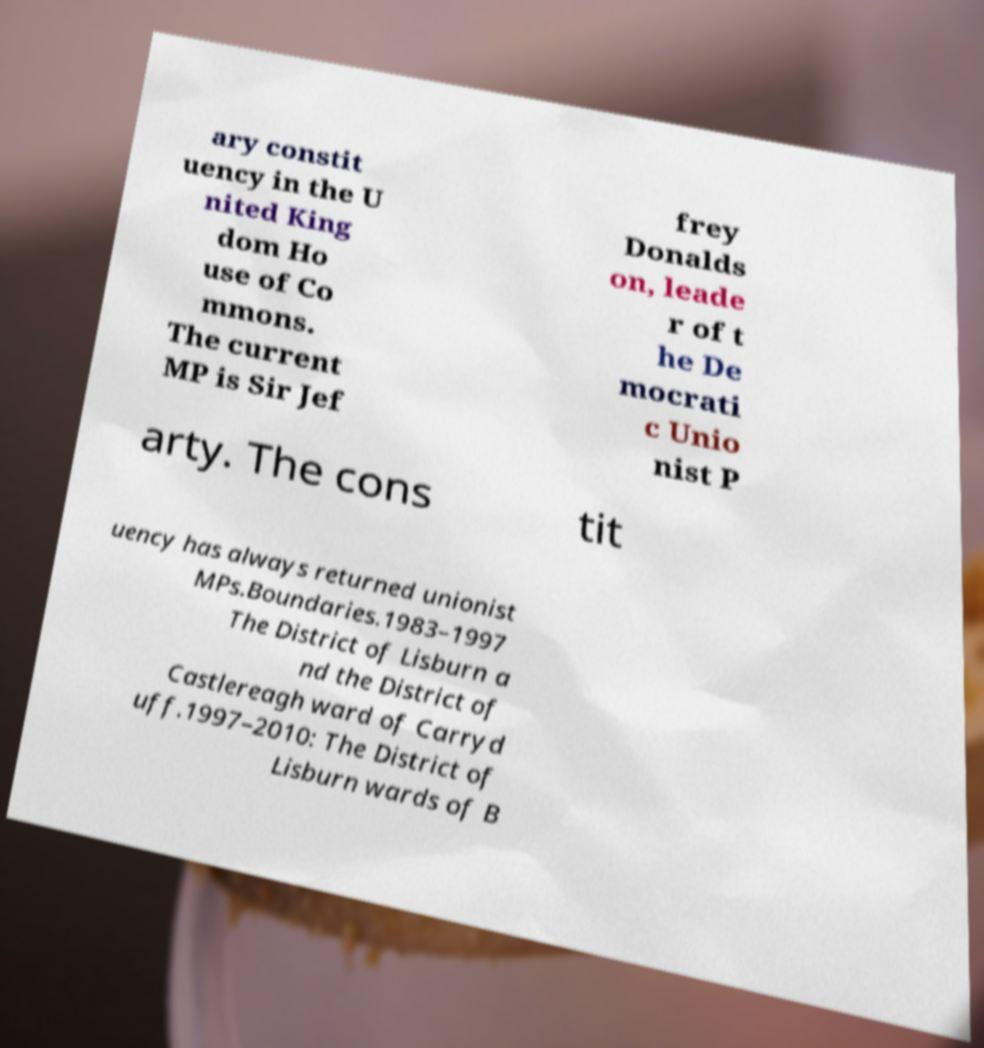Can you accurately transcribe the text from the provided image for me? ary constit uency in the U nited King dom Ho use of Co mmons. The current MP is Sir Jef frey Donalds on, leade r of t he De mocrati c Unio nist P arty. The cons tit uency has always returned unionist MPs.Boundaries.1983–1997 The District of Lisburn a nd the District of Castlereagh ward of Carryd uff.1997–2010: The District of Lisburn wards of B 